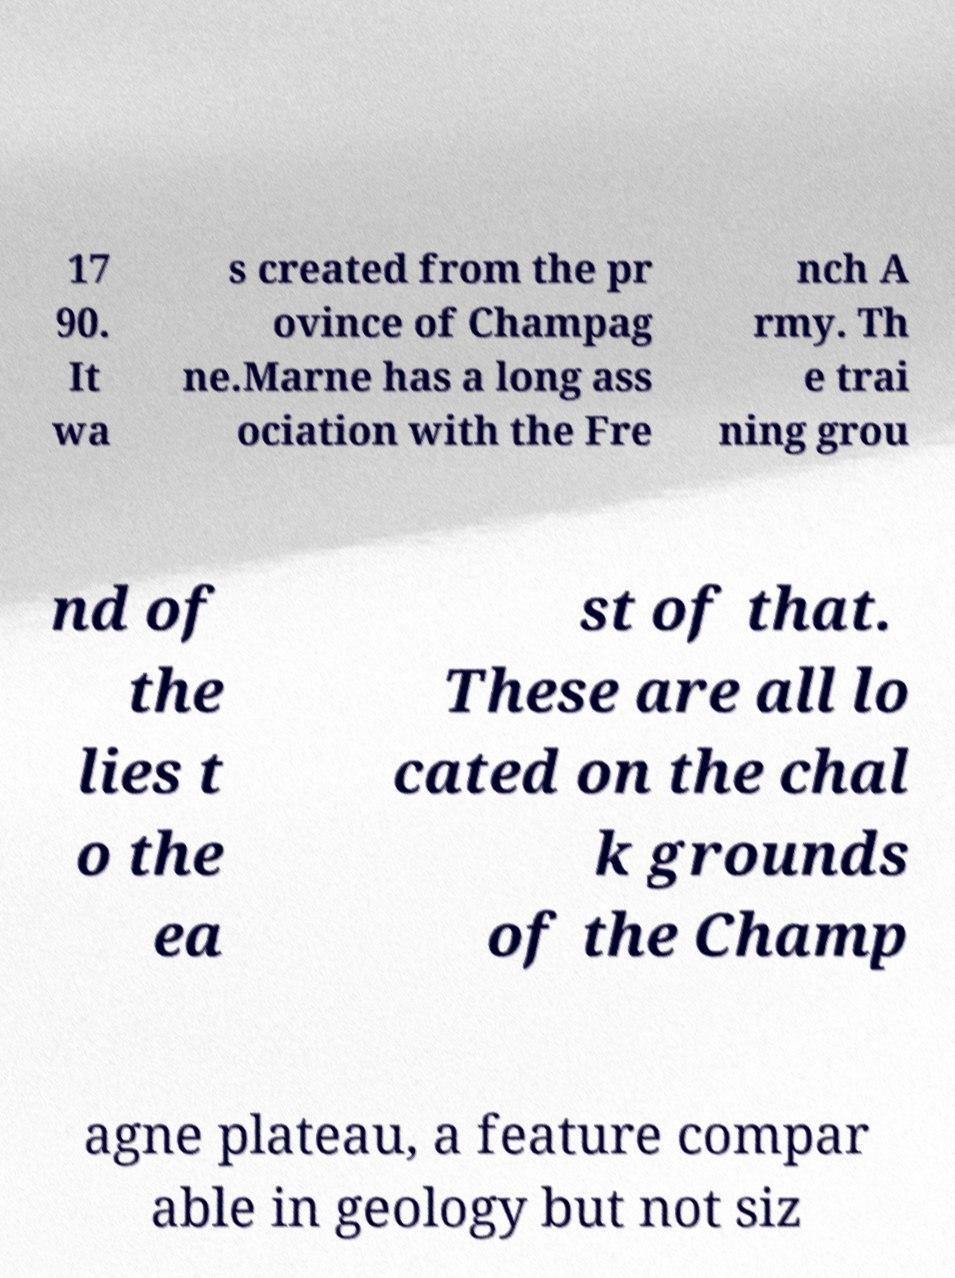Can you accurately transcribe the text from the provided image for me? 17 90. It wa s created from the pr ovince of Champag ne.Marne has a long ass ociation with the Fre nch A rmy. Th e trai ning grou nd of the lies t o the ea st of that. These are all lo cated on the chal k grounds of the Champ agne plateau, a feature compar able in geology but not siz 